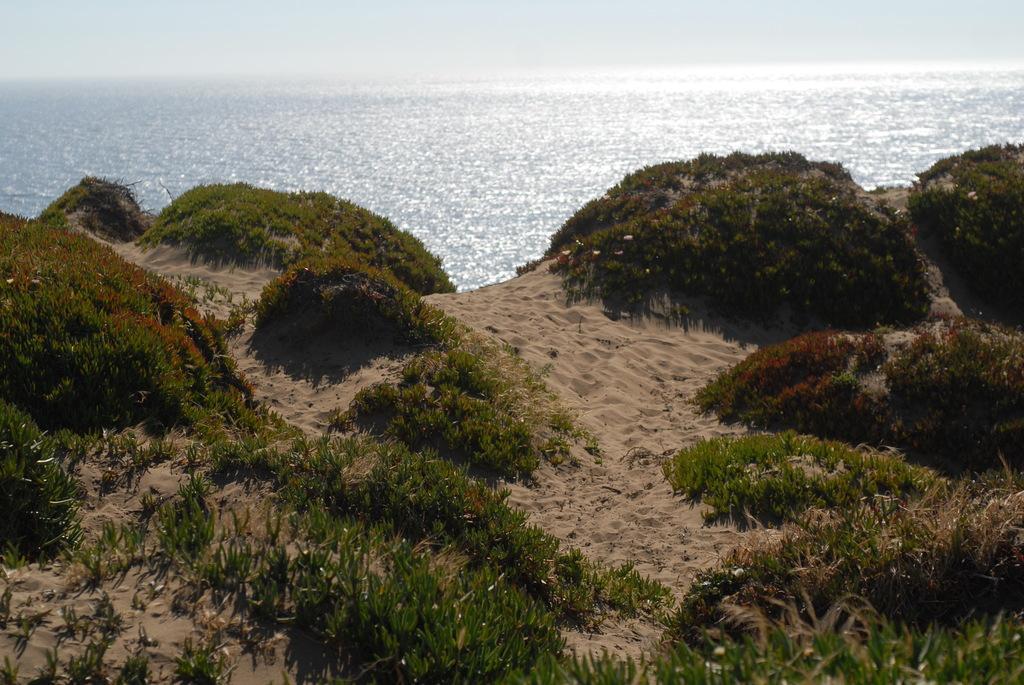In one or two sentences, can you explain what this image depicts? In this image in the front there's grass on the ground and there are plants. In the background there is an ocean. 